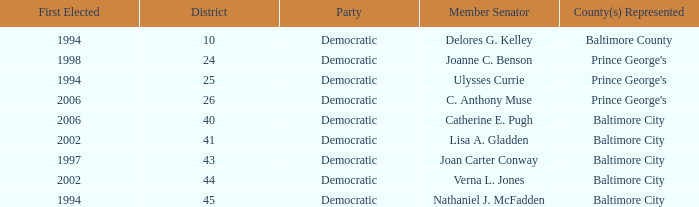Who was firest elected in 2002 in a district larger than 41? Verna L. Jones. 